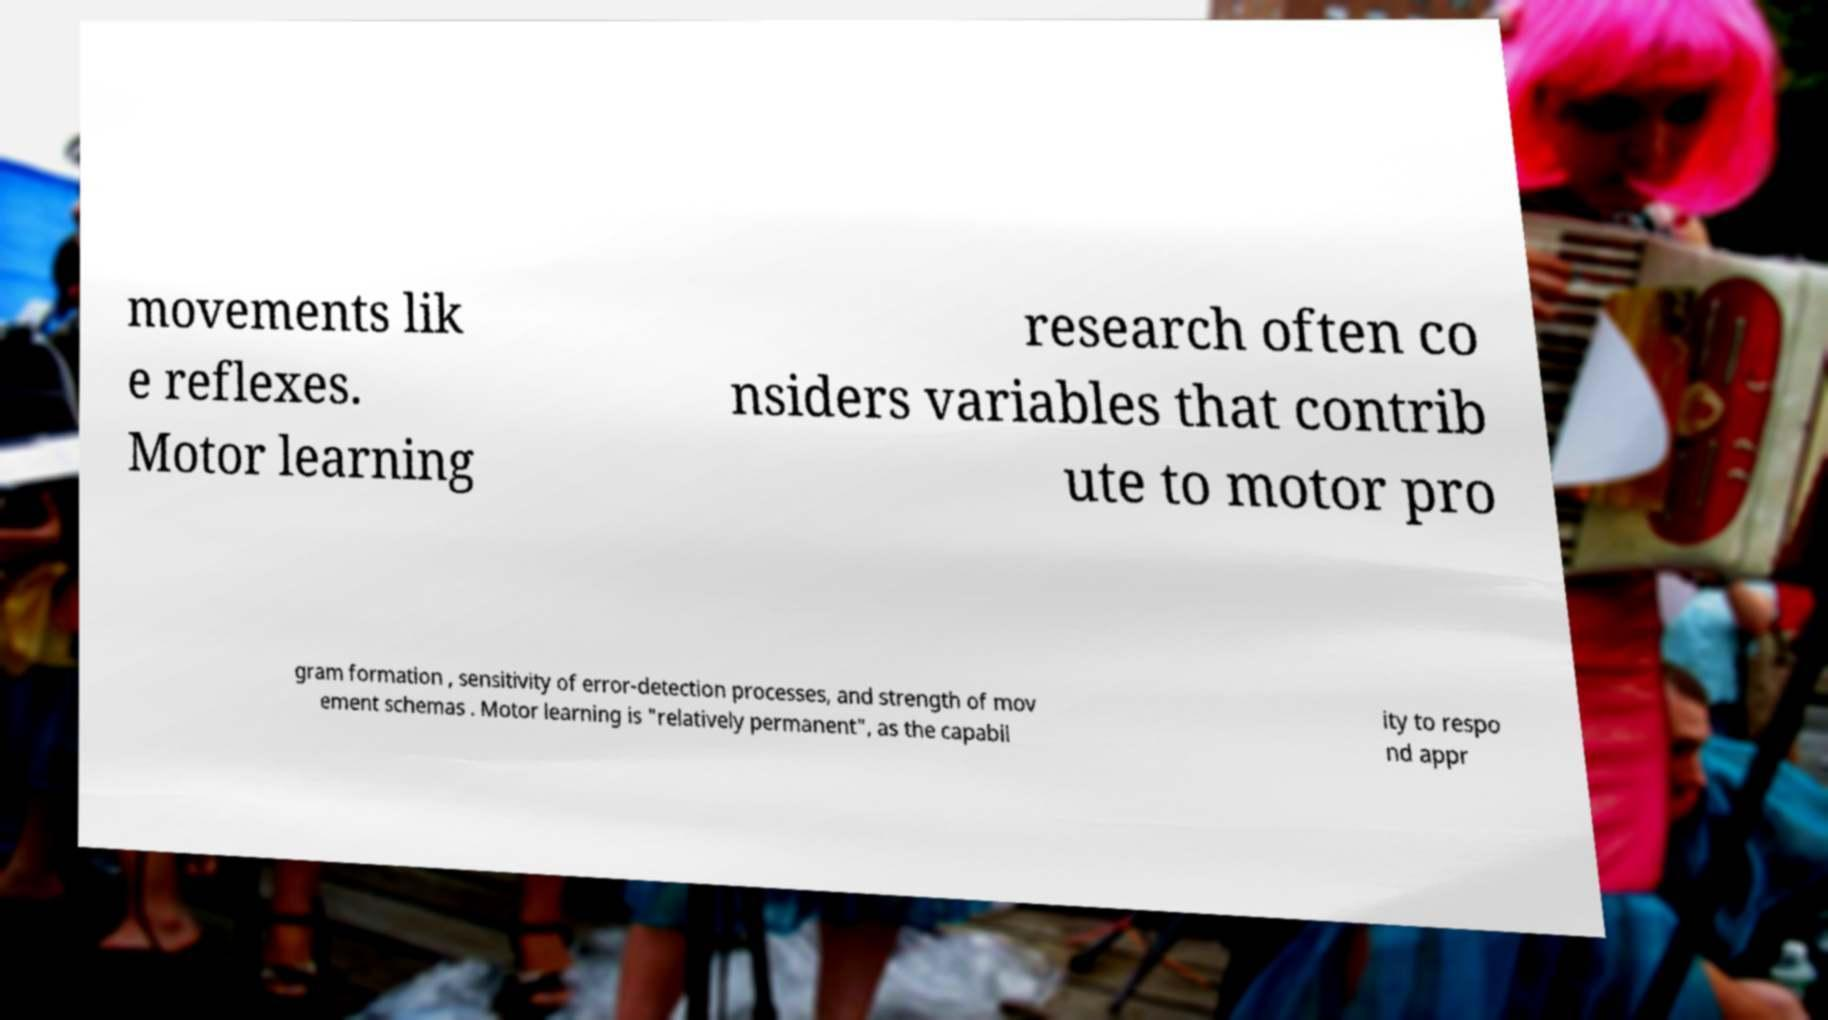Could you assist in decoding the text presented in this image and type it out clearly? movements lik e reflexes. Motor learning research often co nsiders variables that contrib ute to motor pro gram formation , sensitivity of error-detection processes, and strength of mov ement schemas . Motor learning is "relatively permanent", as the capabil ity to respo nd appr 